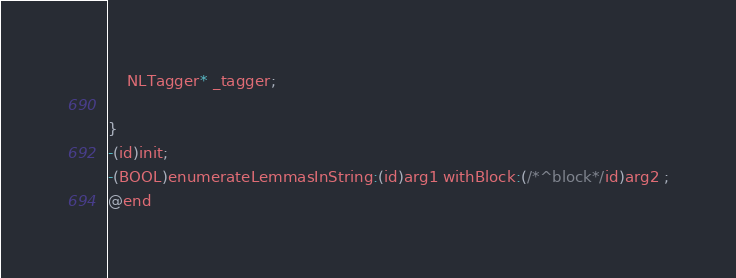Convert code to text. <code><loc_0><loc_0><loc_500><loc_500><_C_>
	NLTagger* _tagger;

}
-(id)init;
-(BOOL)enumerateLemmasInString:(id)arg1 withBlock:(/*^block*/id)arg2 ;
@end

</code> 